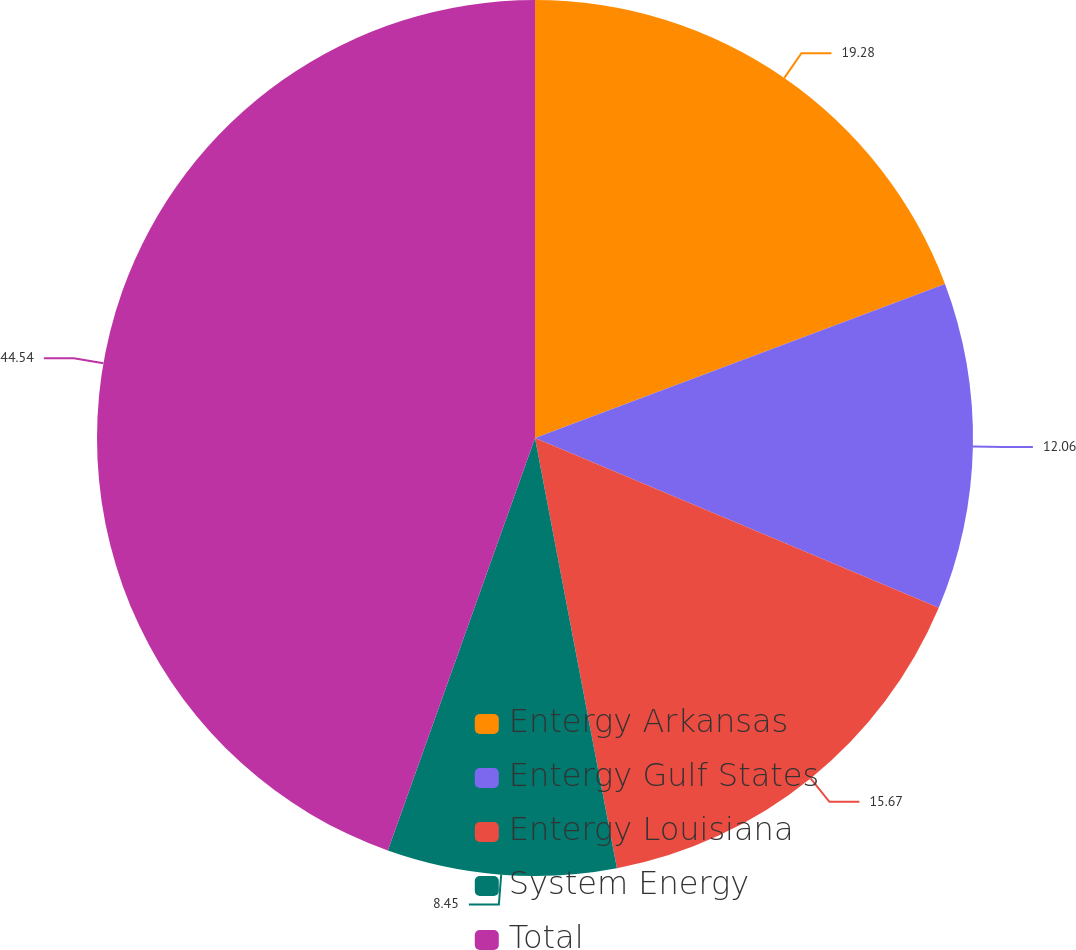<chart> <loc_0><loc_0><loc_500><loc_500><pie_chart><fcel>Entergy Arkansas<fcel>Entergy Gulf States<fcel>Entergy Louisiana<fcel>System Energy<fcel>Total<nl><fcel>19.28%<fcel>12.06%<fcel>15.67%<fcel>8.45%<fcel>44.55%<nl></chart> 